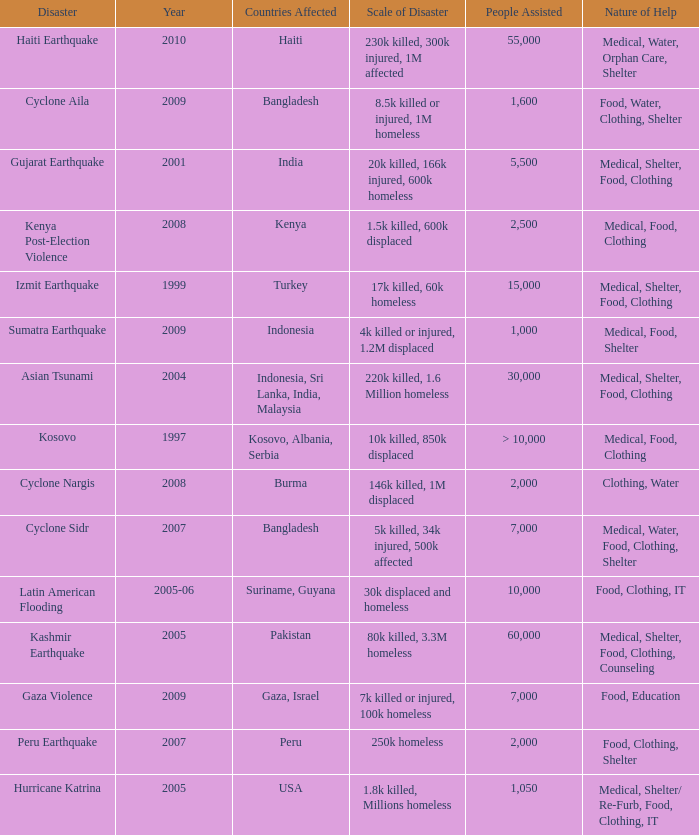Which year did USA undergo a disaster? 2005.0. 